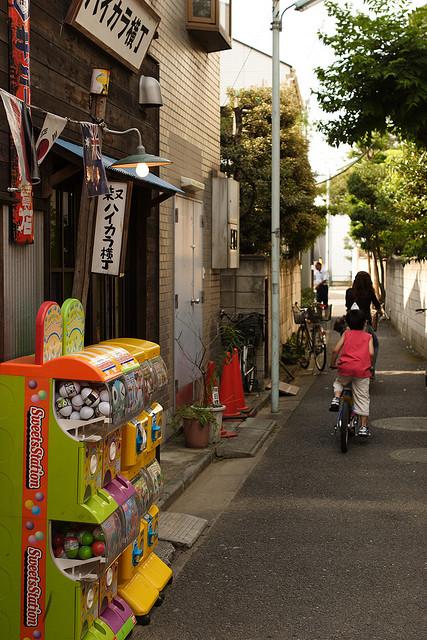What language are the signs written in?
Keep it brief. Chinese. What country is this?
Short answer required. Japan. Are the cones blocking the street?
Short answer required. No. What color is the vending machine?
Write a very short answer. Green and yellow. 